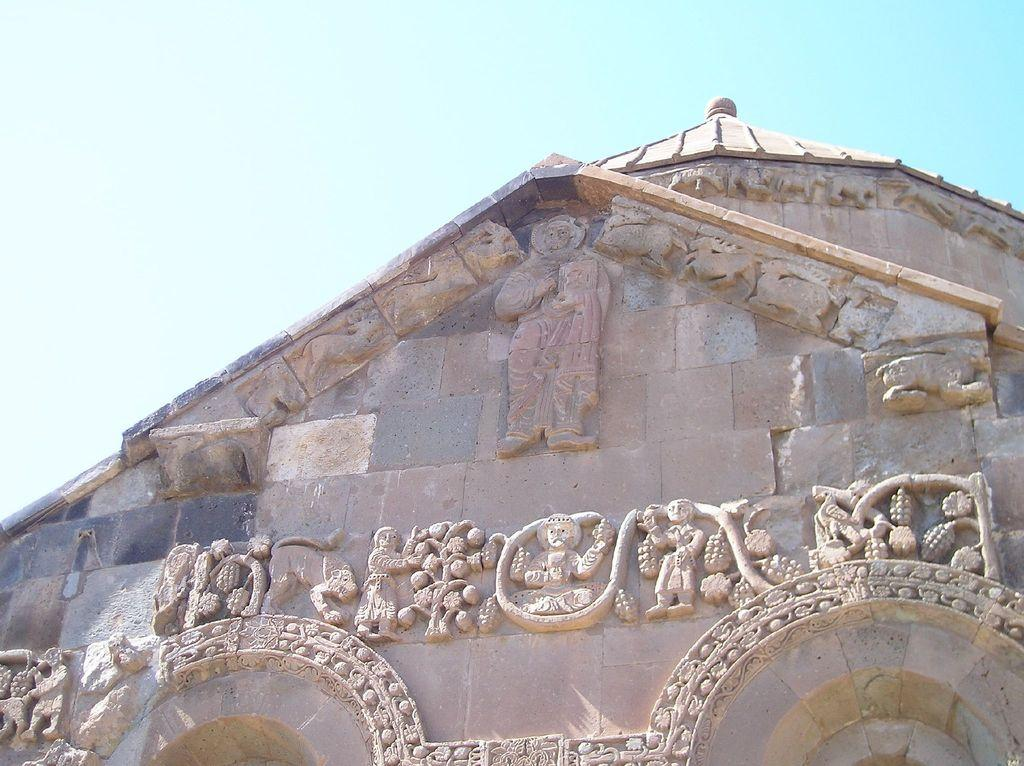What type of structure is partially visible in the image? There is a part of a building in the image. What decorative elements can be seen on the building? There are sculptures on the wall of the building. What is visible at the top of the image? The sky is visible at the top of the image. How many tents are set up in the camp shown in the image? There is no camp or tents present in the image; it features a part of a building with sculptures on the wall and a visible sky. 